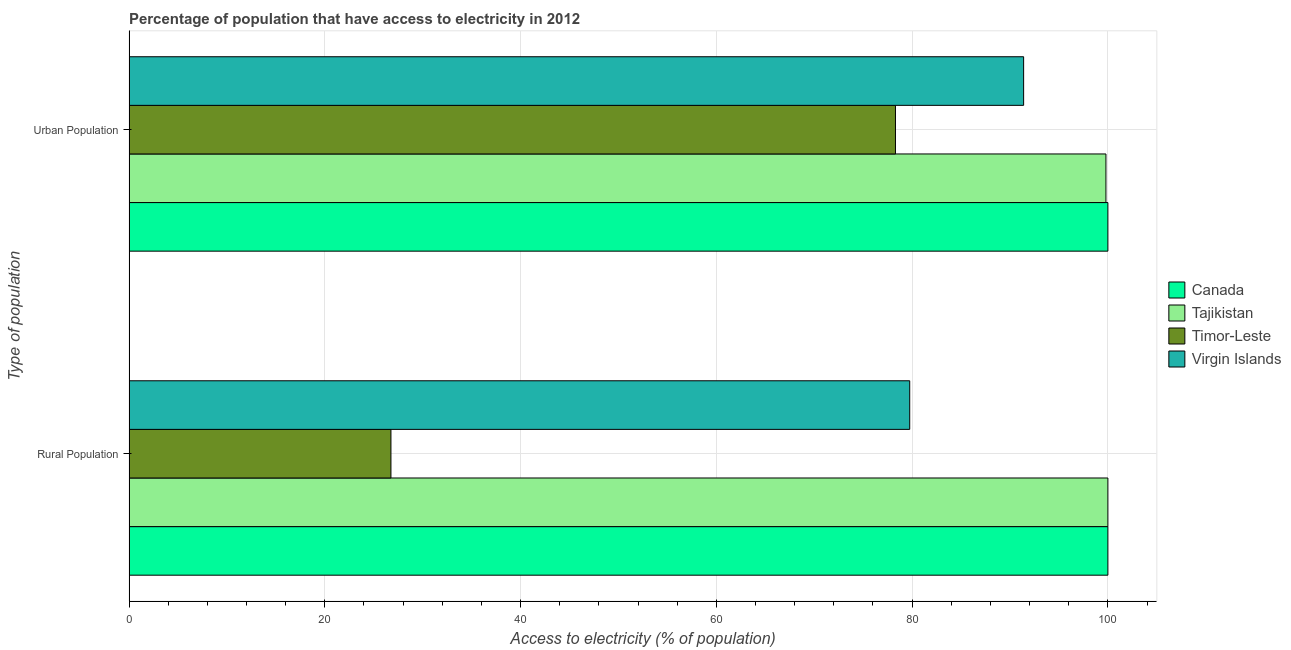How many groups of bars are there?
Your answer should be compact. 2. Are the number of bars on each tick of the Y-axis equal?
Provide a short and direct response. Yes. What is the label of the 2nd group of bars from the top?
Offer a very short reply. Rural Population. What is the percentage of rural population having access to electricity in Canada?
Offer a terse response. 100. Across all countries, what is the maximum percentage of rural population having access to electricity?
Your response must be concise. 100. Across all countries, what is the minimum percentage of rural population having access to electricity?
Your answer should be very brief. 26.75. In which country was the percentage of urban population having access to electricity maximum?
Make the answer very short. Canada. In which country was the percentage of urban population having access to electricity minimum?
Ensure brevity in your answer.  Timor-Leste. What is the total percentage of urban population having access to electricity in the graph?
Your answer should be compact. 369.49. What is the difference between the percentage of urban population having access to electricity in Timor-Leste and that in Tajikistan?
Provide a short and direct response. -21.5. What is the difference between the percentage of urban population having access to electricity in Virgin Islands and the percentage of rural population having access to electricity in Tajikistan?
Your answer should be very brief. -8.61. What is the average percentage of urban population having access to electricity per country?
Your answer should be very brief. 92.37. What is the difference between the percentage of rural population having access to electricity and percentage of urban population having access to electricity in Tajikistan?
Make the answer very short. 0.2. In how many countries, is the percentage of urban population having access to electricity greater than 100 %?
Make the answer very short. 0. What is the ratio of the percentage of rural population having access to electricity in Virgin Islands to that in Canada?
Your response must be concise. 0.8. Is the percentage of rural population having access to electricity in Timor-Leste less than that in Canada?
Your answer should be compact. Yes. In how many countries, is the percentage of urban population having access to electricity greater than the average percentage of urban population having access to electricity taken over all countries?
Offer a terse response. 2. What does the 3rd bar from the top in Urban Population represents?
Offer a very short reply. Tajikistan. What does the 4th bar from the bottom in Urban Population represents?
Your answer should be very brief. Virgin Islands. How many bars are there?
Offer a very short reply. 8. Are all the bars in the graph horizontal?
Make the answer very short. Yes. How many countries are there in the graph?
Give a very brief answer. 4. What is the difference between two consecutive major ticks on the X-axis?
Your answer should be compact. 20. Does the graph contain grids?
Keep it short and to the point. Yes. Where does the legend appear in the graph?
Offer a terse response. Center right. How many legend labels are there?
Give a very brief answer. 4. How are the legend labels stacked?
Keep it short and to the point. Vertical. What is the title of the graph?
Offer a terse response. Percentage of population that have access to electricity in 2012. What is the label or title of the X-axis?
Your response must be concise. Access to electricity (% of population). What is the label or title of the Y-axis?
Give a very brief answer. Type of population. What is the Access to electricity (% of population) in Canada in Rural Population?
Provide a succinct answer. 100. What is the Access to electricity (% of population) of Timor-Leste in Rural Population?
Your answer should be very brief. 26.75. What is the Access to electricity (% of population) of Virgin Islands in Rural Population?
Ensure brevity in your answer.  79.75. What is the Access to electricity (% of population) of Tajikistan in Urban Population?
Provide a succinct answer. 99.8. What is the Access to electricity (% of population) of Timor-Leste in Urban Population?
Provide a short and direct response. 78.3. What is the Access to electricity (% of population) in Virgin Islands in Urban Population?
Offer a terse response. 91.39. Across all Type of population, what is the maximum Access to electricity (% of population) in Canada?
Your response must be concise. 100. Across all Type of population, what is the maximum Access to electricity (% of population) in Timor-Leste?
Offer a very short reply. 78.3. Across all Type of population, what is the maximum Access to electricity (% of population) of Virgin Islands?
Provide a short and direct response. 91.39. Across all Type of population, what is the minimum Access to electricity (% of population) in Canada?
Ensure brevity in your answer.  100. Across all Type of population, what is the minimum Access to electricity (% of population) in Tajikistan?
Offer a very short reply. 99.8. Across all Type of population, what is the minimum Access to electricity (% of population) of Timor-Leste?
Provide a short and direct response. 26.75. Across all Type of population, what is the minimum Access to electricity (% of population) in Virgin Islands?
Your answer should be very brief. 79.75. What is the total Access to electricity (% of population) of Tajikistan in the graph?
Give a very brief answer. 199.8. What is the total Access to electricity (% of population) of Timor-Leste in the graph?
Give a very brief answer. 105.05. What is the total Access to electricity (% of population) in Virgin Islands in the graph?
Provide a short and direct response. 171.15. What is the difference between the Access to electricity (% of population) in Canada in Rural Population and that in Urban Population?
Ensure brevity in your answer.  0. What is the difference between the Access to electricity (% of population) of Timor-Leste in Rural Population and that in Urban Population?
Your answer should be very brief. -51.54. What is the difference between the Access to electricity (% of population) in Virgin Islands in Rural Population and that in Urban Population?
Your answer should be very brief. -11.64. What is the difference between the Access to electricity (% of population) of Canada in Rural Population and the Access to electricity (% of population) of Tajikistan in Urban Population?
Your answer should be compact. 0.2. What is the difference between the Access to electricity (% of population) of Canada in Rural Population and the Access to electricity (% of population) of Timor-Leste in Urban Population?
Your response must be concise. 21.7. What is the difference between the Access to electricity (% of population) of Canada in Rural Population and the Access to electricity (% of population) of Virgin Islands in Urban Population?
Your response must be concise. 8.61. What is the difference between the Access to electricity (% of population) of Tajikistan in Rural Population and the Access to electricity (% of population) of Timor-Leste in Urban Population?
Offer a very short reply. 21.7. What is the difference between the Access to electricity (% of population) of Tajikistan in Rural Population and the Access to electricity (% of population) of Virgin Islands in Urban Population?
Make the answer very short. 8.61. What is the difference between the Access to electricity (% of population) in Timor-Leste in Rural Population and the Access to electricity (% of population) in Virgin Islands in Urban Population?
Give a very brief answer. -64.64. What is the average Access to electricity (% of population) in Tajikistan per Type of population?
Offer a terse response. 99.9. What is the average Access to electricity (% of population) of Timor-Leste per Type of population?
Make the answer very short. 52.53. What is the average Access to electricity (% of population) of Virgin Islands per Type of population?
Provide a short and direct response. 85.57. What is the difference between the Access to electricity (% of population) of Canada and Access to electricity (% of population) of Timor-Leste in Rural Population?
Your answer should be very brief. 73.25. What is the difference between the Access to electricity (% of population) of Canada and Access to electricity (% of population) of Virgin Islands in Rural Population?
Your answer should be compact. 20.25. What is the difference between the Access to electricity (% of population) of Tajikistan and Access to electricity (% of population) of Timor-Leste in Rural Population?
Offer a very short reply. 73.25. What is the difference between the Access to electricity (% of population) of Tajikistan and Access to electricity (% of population) of Virgin Islands in Rural Population?
Provide a succinct answer. 20.25. What is the difference between the Access to electricity (% of population) in Timor-Leste and Access to electricity (% of population) in Virgin Islands in Rural Population?
Give a very brief answer. -53. What is the difference between the Access to electricity (% of population) of Canada and Access to electricity (% of population) of Timor-Leste in Urban Population?
Offer a terse response. 21.7. What is the difference between the Access to electricity (% of population) of Canada and Access to electricity (% of population) of Virgin Islands in Urban Population?
Your answer should be compact. 8.61. What is the difference between the Access to electricity (% of population) in Tajikistan and Access to electricity (% of population) in Timor-Leste in Urban Population?
Your answer should be compact. 21.5. What is the difference between the Access to electricity (% of population) of Tajikistan and Access to electricity (% of population) of Virgin Islands in Urban Population?
Your response must be concise. 8.41. What is the difference between the Access to electricity (% of population) in Timor-Leste and Access to electricity (% of population) in Virgin Islands in Urban Population?
Your answer should be very brief. -13.09. What is the ratio of the Access to electricity (% of population) in Canada in Rural Population to that in Urban Population?
Your answer should be compact. 1. What is the ratio of the Access to electricity (% of population) of Timor-Leste in Rural Population to that in Urban Population?
Your answer should be very brief. 0.34. What is the ratio of the Access to electricity (% of population) of Virgin Islands in Rural Population to that in Urban Population?
Provide a succinct answer. 0.87. What is the difference between the highest and the second highest Access to electricity (% of population) of Timor-Leste?
Ensure brevity in your answer.  51.54. What is the difference between the highest and the second highest Access to electricity (% of population) of Virgin Islands?
Your answer should be very brief. 11.64. What is the difference between the highest and the lowest Access to electricity (% of population) of Canada?
Provide a succinct answer. 0. What is the difference between the highest and the lowest Access to electricity (% of population) in Timor-Leste?
Give a very brief answer. 51.54. What is the difference between the highest and the lowest Access to electricity (% of population) of Virgin Islands?
Make the answer very short. 11.64. 